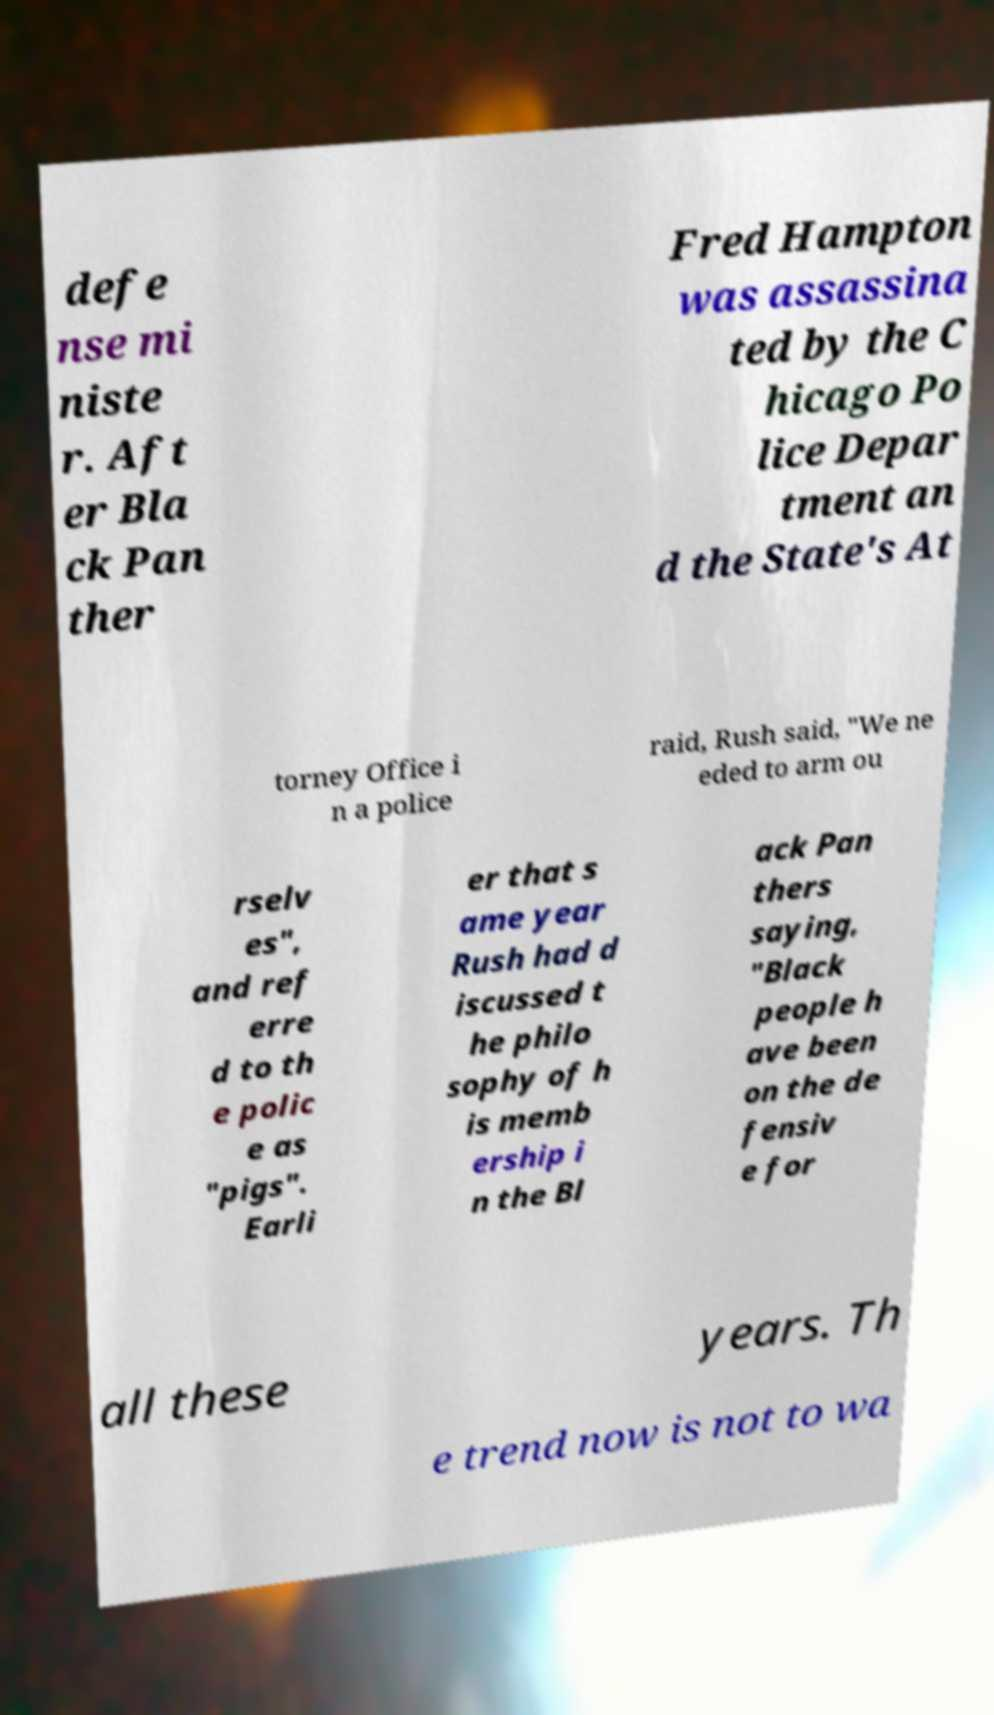Could you assist in decoding the text presented in this image and type it out clearly? defe nse mi niste r. Aft er Bla ck Pan ther Fred Hampton was assassina ted by the C hicago Po lice Depar tment an d the State's At torney Office i n a police raid, Rush said, "We ne eded to arm ou rselv es", and ref erre d to th e polic e as "pigs". Earli er that s ame year Rush had d iscussed t he philo sophy of h is memb ership i n the Bl ack Pan thers saying, "Black people h ave been on the de fensiv e for all these years. Th e trend now is not to wa 